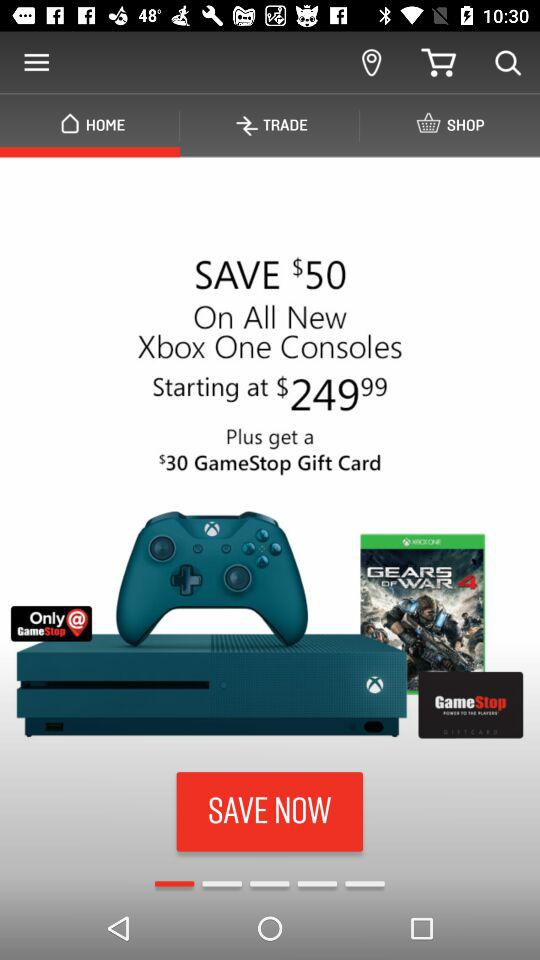Which tab is selected? The selected tab is "HOME". 